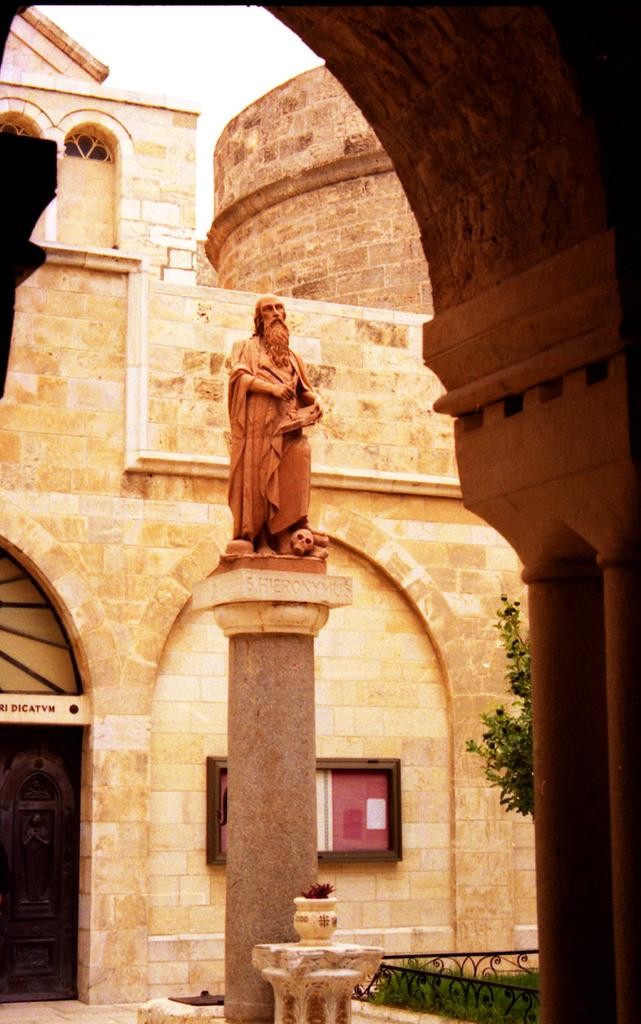What is the main subject of the image? There is a sculpture in the image. What is unique about the sculpture? The sculpture is wearing clothes. What type of structure can be seen in the image? There is a stone building in the image. Can you describe any architectural features in the image? Yes, there is a pillar and an arch in the image. What type of vegetation is present in the image? Grass and a plant are present in the image. What is visible in the background of the image? The sky is visible in the image. What other object can be seen in the image? There is a board in the image. What type of juice is being served in the image? There is no juice present in the image; it features a sculpture, a stone building, and other architectural elements. 